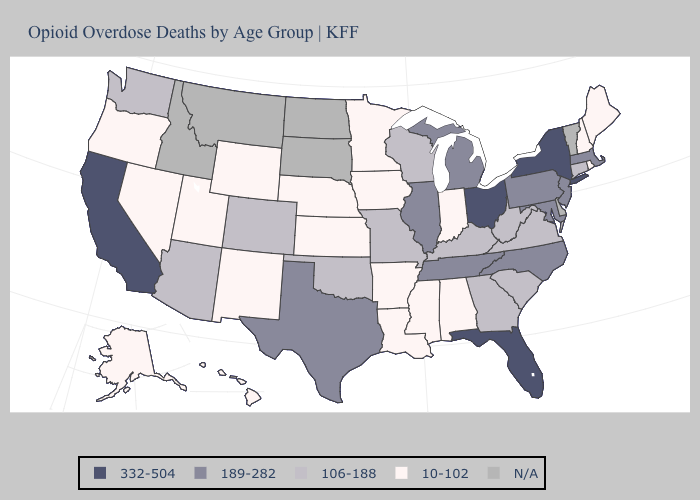Does Ohio have the lowest value in the USA?
Keep it brief. No. Among the states that border South Carolina , which have the lowest value?
Be succinct. Georgia. Name the states that have a value in the range N/A?
Short answer required. Delaware, Idaho, Montana, North Dakota, South Dakota, Vermont. Name the states that have a value in the range 189-282?
Answer briefly. Illinois, Maryland, Massachusetts, Michigan, New Jersey, North Carolina, Pennsylvania, Tennessee, Texas. Which states have the lowest value in the USA?
Be succinct. Alabama, Alaska, Arkansas, Hawaii, Indiana, Iowa, Kansas, Louisiana, Maine, Minnesota, Mississippi, Nebraska, Nevada, New Hampshire, New Mexico, Oregon, Rhode Island, Utah, Wyoming. Name the states that have a value in the range 332-504?
Write a very short answer. California, Florida, New York, Ohio. What is the value of South Carolina?
Give a very brief answer. 106-188. Name the states that have a value in the range 332-504?
Short answer required. California, Florida, New York, Ohio. Does the first symbol in the legend represent the smallest category?
Concise answer only. No. Does Iowa have the lowest value in the USA?
Quick response, please. Yes. What is the value of West Virginia?
Be succinct. 106-188. What is the lowest value in the Northeast?
Write a very short answer. 10-102. Among the states that border Oregon , which have the highest value?
Concise answer only. California. Does North Carolina have the lowest value in the USA?
Concise answer only. No. Name the states that have a value in the range 106-188?
Concise answer only. Arizona, Colorado, Connecticut, Georgia, Kentucky, Missouri, Oklahoma, South Carolina, Virginia, Washington, West Virginia, Wisconsin. 